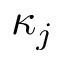<formula> <loc_0><loc_0><loc_500><loc_500>\kappa _ { j }</formula> 